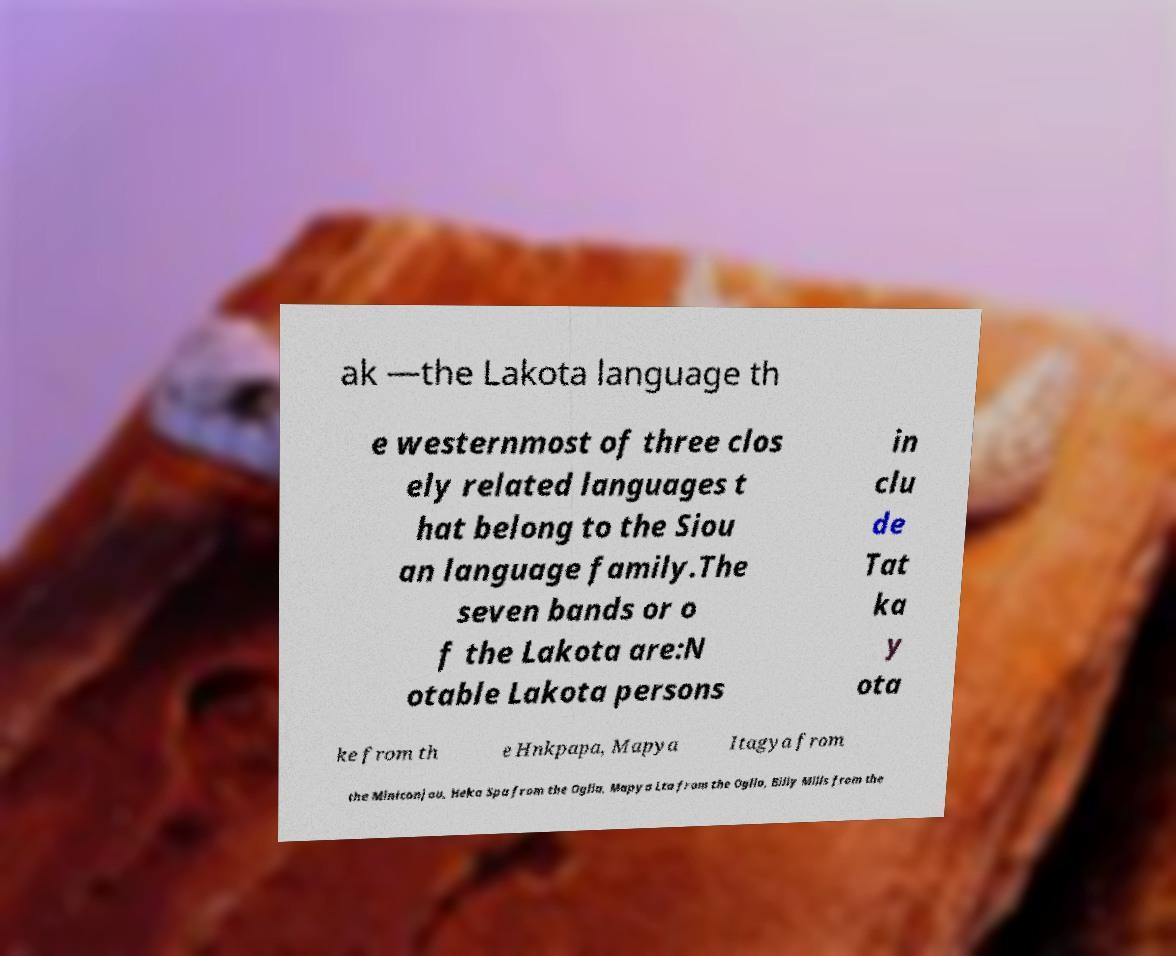Can you accurately transcribe the text from the provided image for me? ak —the Lakota language th e westernmost of three clos ely related languages t hat belong to the Siou an language family.The seven bands or o f the Lakota are:N otable Lakota persons in clu de Tat ka y ota ke from th e Hnkpapa, Mapya Itagya from the Miniconjou, Heka Spa from the Oglla, Mapya Lta from the Oglla, Billy Mills from the 